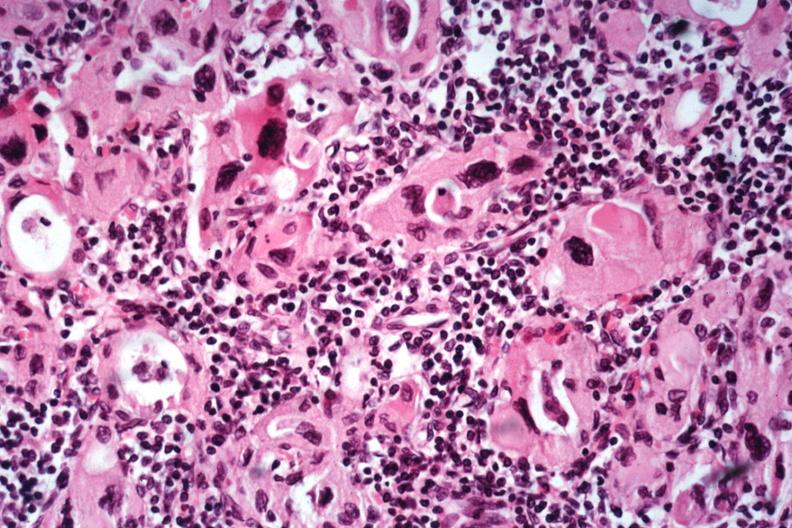s all the fat necrosis present?
Answer the question using a single word or phrase. No 